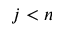<formula> <loc_0><loc_0><loc_500><loc_500>j < n</formula> 